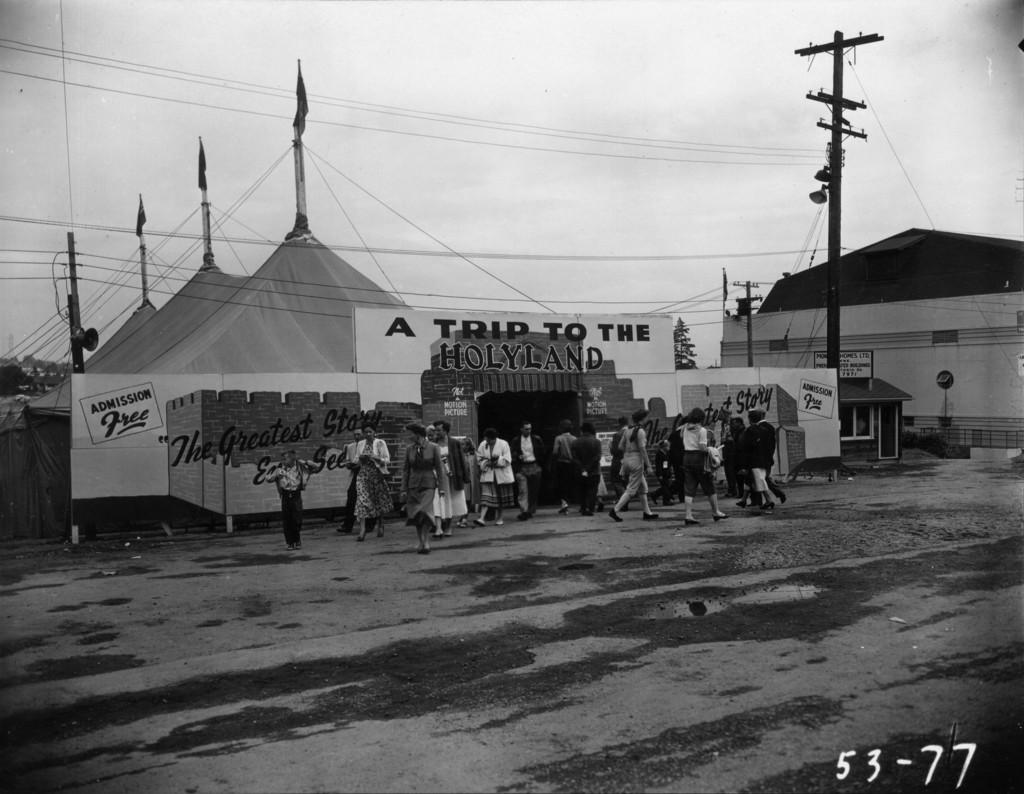What can be seen in the image involving people? There are people standing in the image. What type of temporary shelters are present in the image? There are tents in the image. What structures can be seen supporting electrical infrastructure? Electric poles are visible in the image. What are the cables used for in the image? The cables are present in the image, likely for connecting electrical or communication systems. What type of information is displayed on the boards in the image? There are boards with text in the image. What is visible at the top of the image? The sky is visible at the top of the image. What type of meal is being served in the image? There is no meal present in the image; it features people, tents, electric poles, cables, boards with text, and a visible sky. What scientific theory is being discussed by the people in the image? There is no indication of a scientific discussion or theory in the image. 